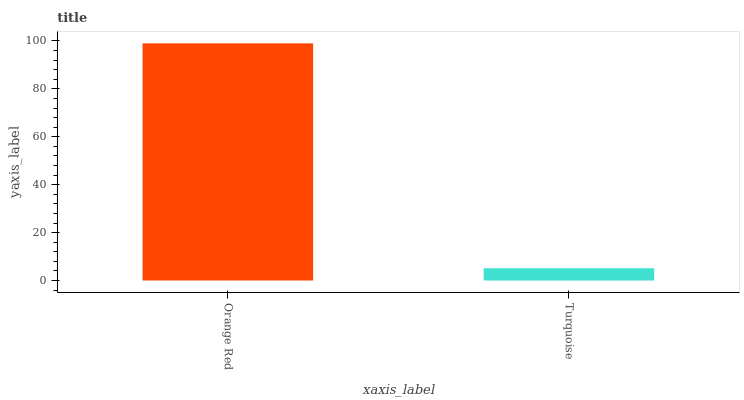Is Turquoise the minimum?
Answer yes or no. Yes. Is Orange Red the maximum?
Answer yes or no. Yes. Is Turquoise the maximum?
Answer yes or no. No. Is Orange Red greater than Turquoise?
Answer yes or no. Yes. Is Turquoise less than Orange Red?
Answer yes or no. Yes. Is Turquoise greater than Orange Red?
Answer yes or no. No. Is Orange Red less than Turquoise?
Answer yes or no. No. Is Orange Red the high median?
Answer yes or no. Yes. Is Turquoise the low median?
Answer yes or no. Yes. Is Turquoise the high median?
Answer yes or no. No. Is Orange Red the low median?
Answer yes or no. No. 